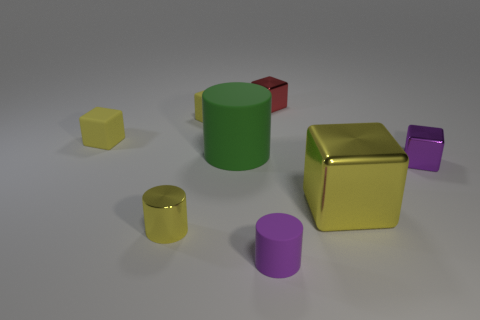Subtract all green cylinders. How many yellow blocks are left? 3 Subtract all gray blocks. Subtract all green balls. How many blocks are left? 5 Add 1 tiny matte things. How many objects exist? 9 Subtract all blocks. How many objects are left? 3 Subtract all tiny purple cylinders. Subtract all tiny purple shiny things. How many objects are left? 6 Add 1 small yellow cubes. How many small yellow cubes are left? 3 Add 5 small rubber cubes. How many small rubber cubes exist? 7 Subtract 0 red balls. How many objects are left? 8 